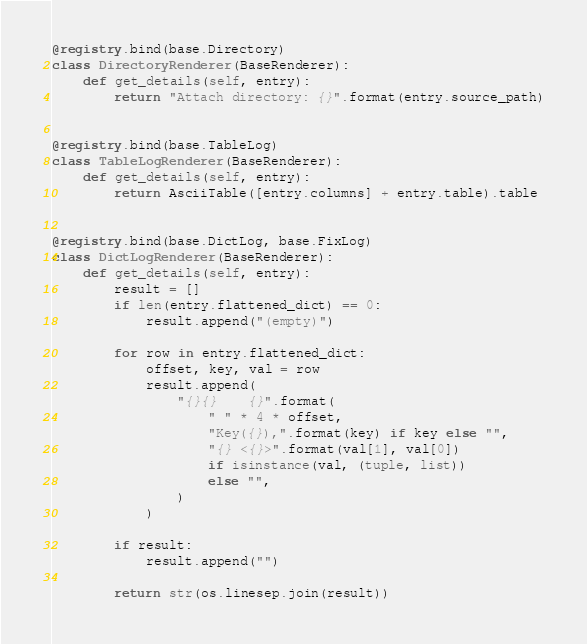<code> <loc_0><loc_0><loc_500><loc_500><_Python_>

@registry.bind(base.Directory)
class DirectoryRenderer(BaseRenderer):
    def get_details(self, entry):
        return "Attach directory: {}".format(entry.source_path)


@registry.bind(base.TableLog)
class TableLogRenderer(BaseRenderer):
    def get_details(self, entry):
        return AsciiTable([entry.columns] + entry.table).table


@registry.bind(base.DictLog, base.FixLog)
class DictLogRenderer(BaseRenderer):
    def get_details(self, entry):
        result = []
        if len(entry.flattened_dict) == 0:
            result.append("(empty)")

        for row in entry.flattened_dict:
            offset, key, val = row
            result.append(
                "{}{}    {}".format(
                    " " * 4 * offset,
                    "Key({}),".format(key) if key else "",
                    "{} <{}>".format(val[1], val[0])
                    if isinstance(val, (tuple, list))
                    else "",
                )
            )

        if result:
            result.append("")

        return str(os.linesep.join(result))
</code> 